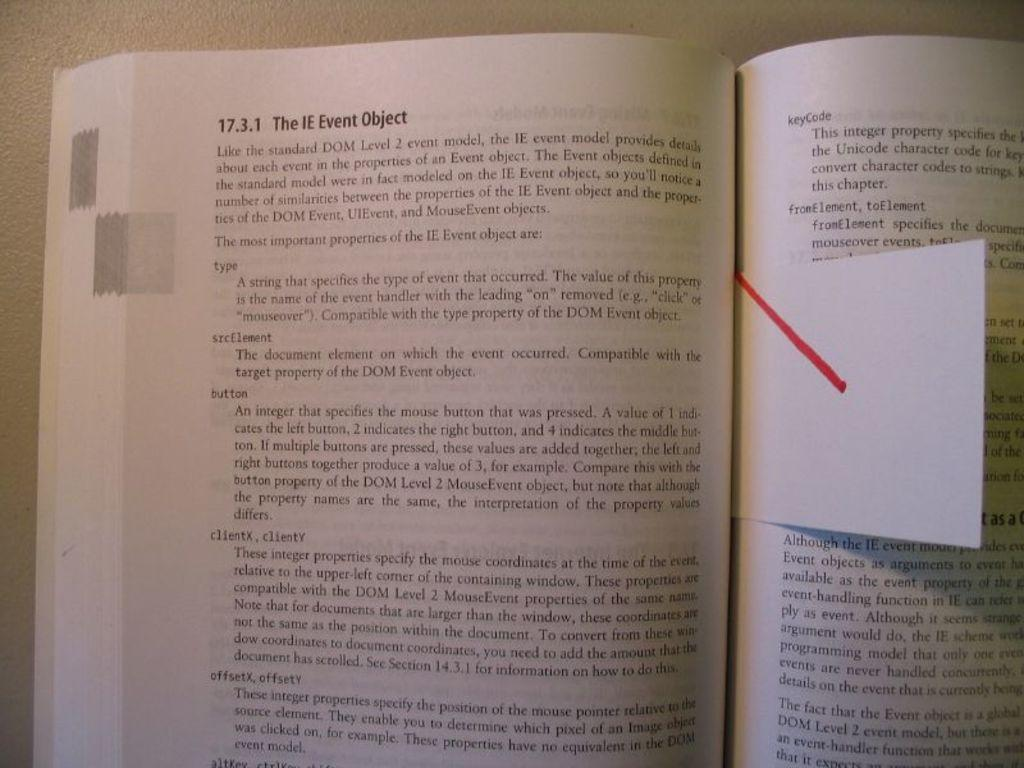<image>
Summarize the visual content of the image. The header of a book identifies a specific section as The IE Event Object. 